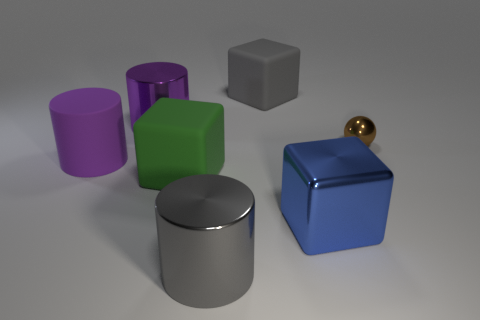What is the material of the blue block that is the same size as the green cube?
Provide a succinct answer. Metal. What shape is the big gray matte object?
Offer a very short reply. Cube. What shape is the matte thing on the right side of the big gray thing that is in front of the gray cube?
Offer a terse response. Cube. There is a big object that is the same color as the big rubber cylinder; what material is it?
Ensure brevity in your answer.  Metal. There is a cube that is made of the same material as the gray cylinder; what is its color?
Your answer should be compact. Blue. Is there anything else that is the same size as the brown metallic sphere?
Offer a very short reply. No. There is a big metallic thing behind the blue shiny object; does it have the same color as the big matte cube in front of the ball?
Keep it short and to the point. No. Are there more large gray metallic objects right of the green cube than shiny spheres that are in front of the tiny brown metallic ball?
Your answer should be compact. Yes. There is a shiny thing that is the same shape as the large green rubber thing; what color is it?
Keep it short and to the point. Blue. Is there anything else that is the same shape as the brown thing?
Offer a terse response. No. 